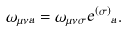<formula> <loc_0><loc_0><loc_500><loc_500>\omega _ { \mu \nu \hat { a } } = \omega _ { \mu \nu \sigma } { e ^ { ( \sigma ) } } _ { a } .</formula> 